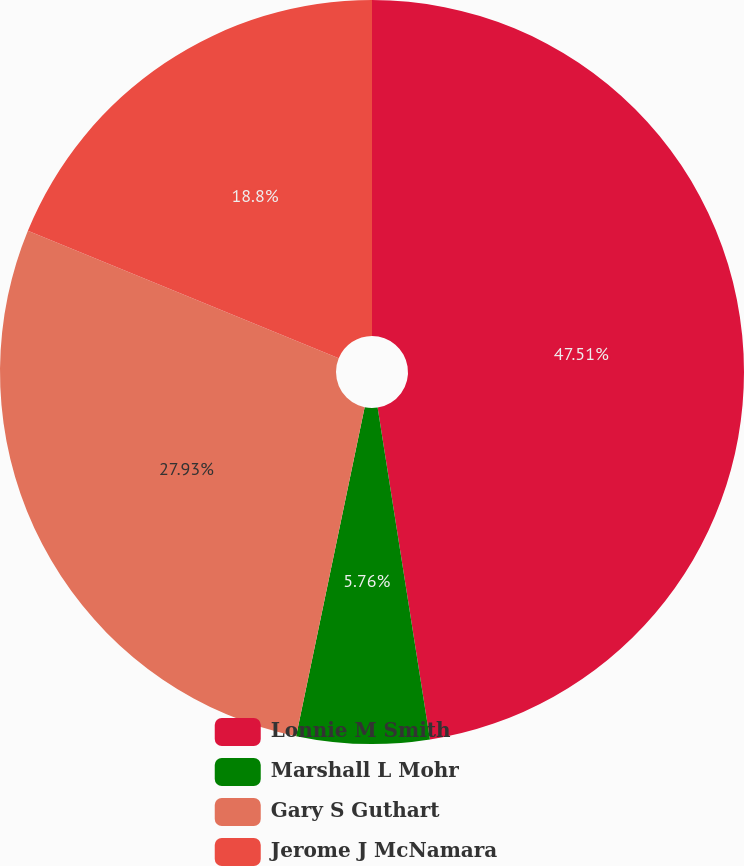<chart> <loc_0><loc_0><loc_500><loc_500><pie_chart><fcel>Lonnie M Smith<fcel>Marshall L Mohr<fcel>Gary S Guthart<fcel>Jerome J McNamara<nl><fcel>47.51%<fcel>5.76%<fcel>27.93%<fcel>18.8%<nl></chart> 